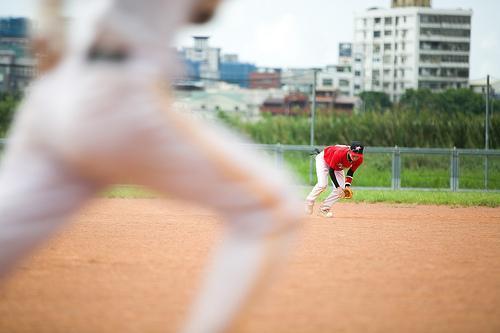How many people are there?
Give a very brief answer. 2. 